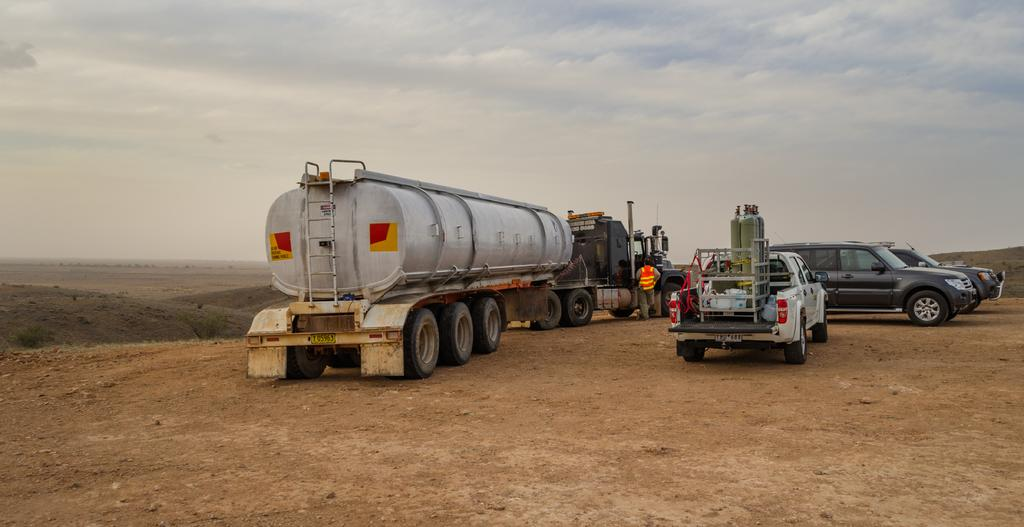What types of objects are on the ground in the image? There are vehicles on the ground in the image. What can be seen in the background of the image? There are clouds and the sky visible in the background of the image. What type of drink is being served in the image? There is no drink present in the image; it features vehicles on the ground and clouds and the sky in the background. 